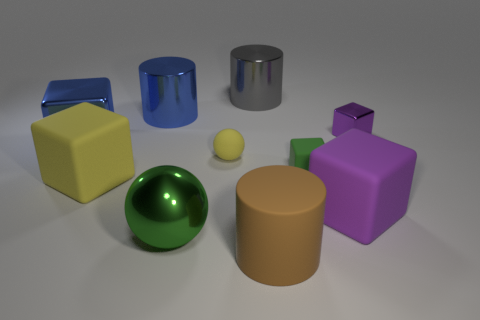What number of objects are matte things to the left of the brown cylinder or rubber objects left of the small matte ball?
Keep it short and to the point. 2. There is a large blue metal thing that is behind the purple thing that is behind the tiny green cube; how many shiny cylinders are behind it?
Provide a short and direct response. 1. What is the size of the metallic thing in front of the small yellow matte ball?
Your answer should be compact. Large. How many purple metal blocks have the same size as the brown thing?
Provide a succinct answer. 0. Do the green metal ball and the block that is in front of the large yellow matte thing have the same size?
Your answer should be very brief. Yes. How many objects are purple matte blocks or green rubber cylinders?
Your answer should be very brief. 1. How many big matte objects have the same color as the small shiny thing?
Keep it short and to the point. 1. The purple object that is the same size as the blue metal cube is what shape?
Your response must be concise. Cube. Are there any small purple rubber objects that have the same shape as the small metal thing?
Offer a terse response. No. What number of brown cylinders are the same material as the small green cube?
Offer a very short reply. 1. 